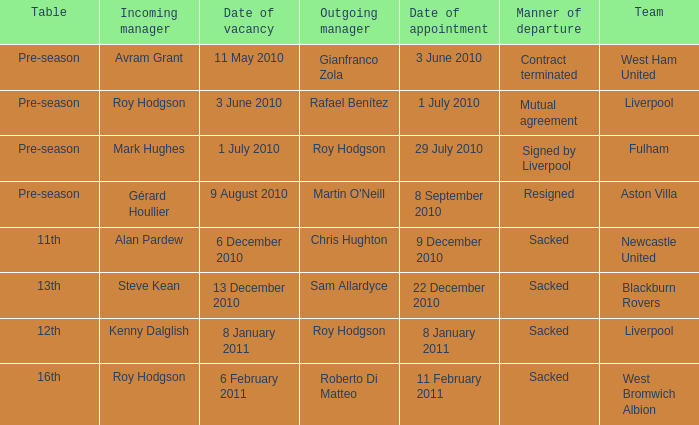How many incoming managers were there after Roy Hodgson left the position for the Fulham team? 1.0. 